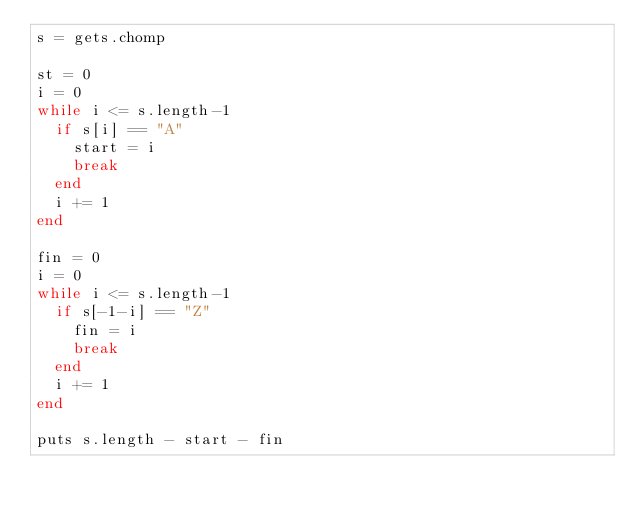Convert code to text. <code><loc_0><loc_0><loc_500><loc_500><_Ruby_>s = gets.chomp

st = 0
i = 0
while i <= s.length-1
  if s[i] == "A"
    start = i
    break
  end
  i += 1
end

fin = 0
i = 0
while i <= s.length-1
  if s[-1-i] == "Z"
    fin = i
    break
  end
  i += 1
end

puts s.length - start - fin</code> 